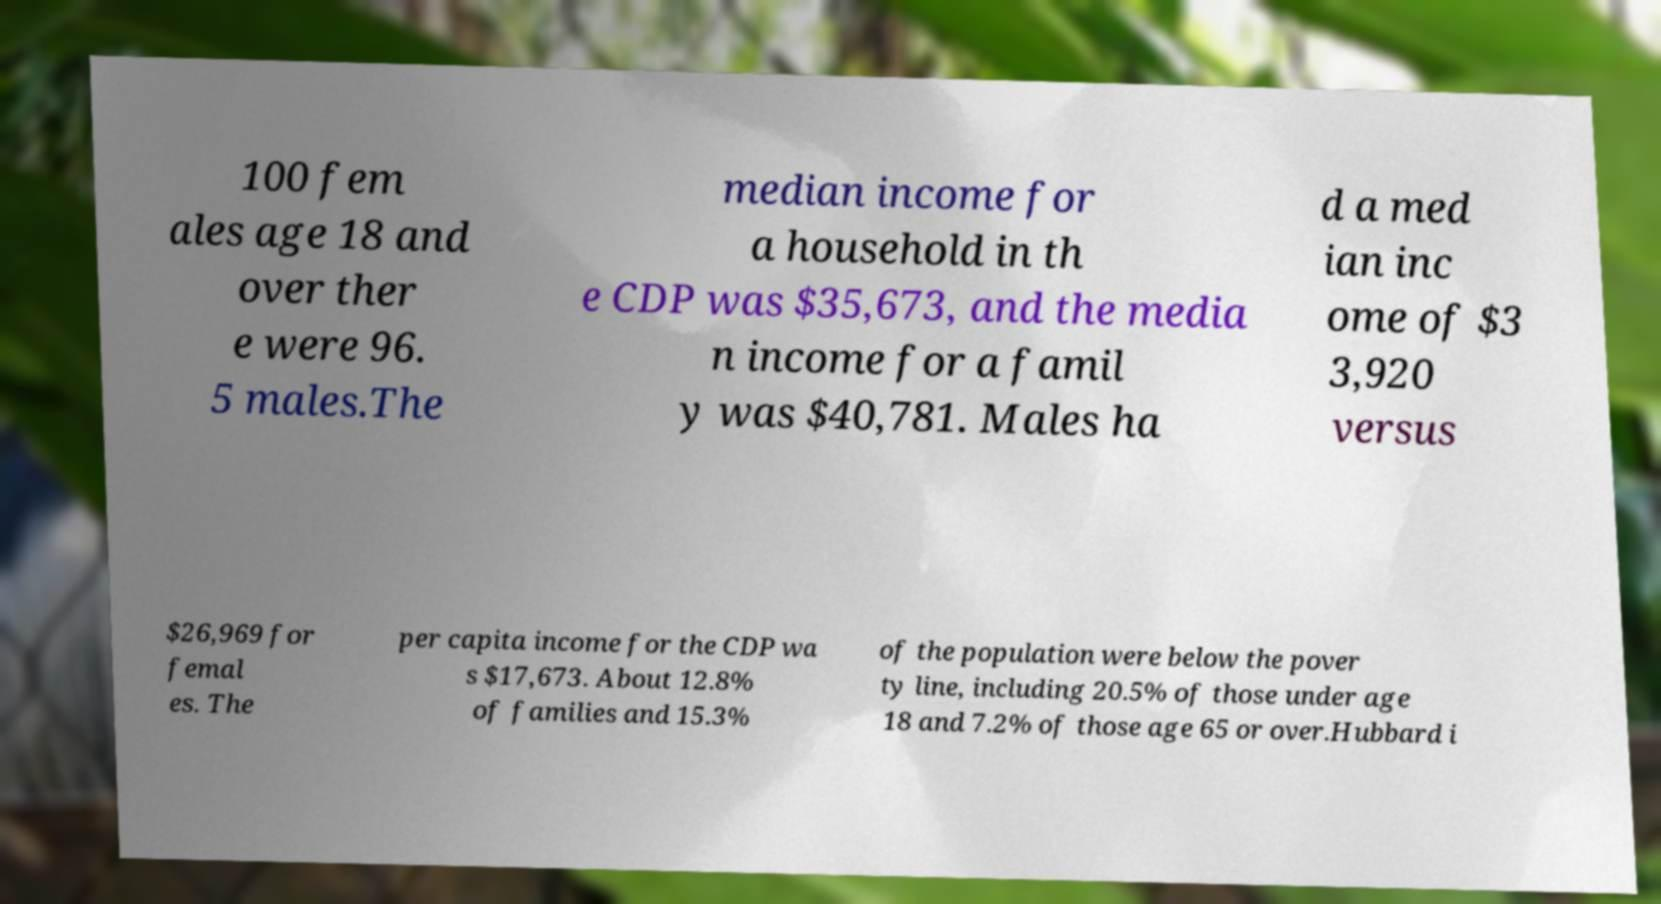I need the written content from this picture converted into text. Can you do that? 100 fem ales age 18 and over ther e were 96. 5 males.The median income for a household in th e CDP was $35,673, and the media n income for a famil y was $40,781. Males ha d a med ian inc ome of $3 3,920 versus $26,969 for femal es. The per capita income for the CDP wa s $17,673. About 12.8% of families and 15.3% of the population were below the pover ty line, including 20.5% of those under age 18 and 7.2% of those age 65 or over.Hubbard i 